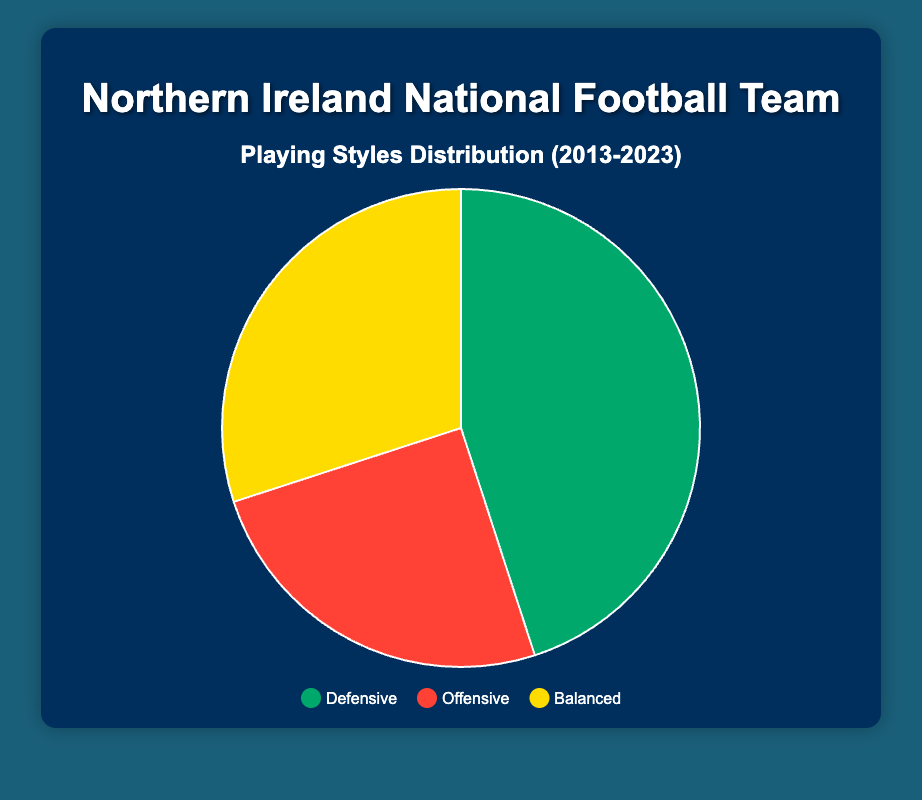What percentage of the Northern Ireland national football team’s playing style is defensive? The defensive segment is shown with a distinct color and is labeled with its percentage. By looking closely at the pie chart, the defensive style accounts for 45%.
Answer: 45% Which playing style is the least common in the Northern Ireland national football team’s distribution? The pie chart divides playing styles into three segments by size. The smallest segment represents the offensive style which accounts for 25%.
Answer: Offensive What is the combined percentage of offensive and balanced playing styles? The pie chart shows the percentages of offensive (25%) and balanced (30%) segments. Adding these two gives 25% + 30% = 55%.
Answer: 55% How does the percentage for balanced playing style compare to that for offensive style? The balanced style is represented as 30% and the offensive style as 25%. Comparing the two, the balanced style has a higher percentage.
Answer: Balanced has a higher percentage Is there a color representing the defensive style? If so, what is it? The legend in the pie chart highlights colors for each style. The defensive style is shown with the color green.
Answer: Green By what percentage does the defensive style exceed the offensive style? Defensive style is 45% and offensive style is 25%. Subtracting the smaller from the larger gives 45% - 25% = 20%.
Answer: 20% Which two segments add up to form the majority percentage of the playing styles? Examining the segments, defensive (45%) and balanced (30%) combine to form 75%, which is a majority.
Answer: Defensive and balanced What is the difference between the balanced and offensive playing styles? Comparing the values, balanced style is 30% and offensive is 25%. The difference is 30% - 25% = 5%.
Answer: 5% What percentage of the pie chart is represented by playing styles other than defensive? Defensive makes up 45%, leaving other styles (balanced 30% and offensive 25%) to form 100% - 45% = 55%.
Answer: 55% What playing style comprises exactly 30% of the distribution? The pie chart specifically indicates the playing style percentages, with the balanced style occupying 30%.
Answer: Balanced 